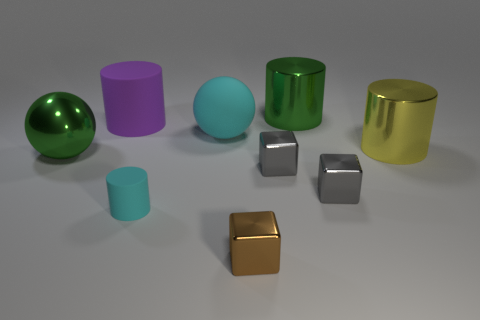Add 1 cyan spheres. How many objects exist? 10 Subtract all cylinders. How many objects are left? 5 Subtract 0 gray spheres. How many objects are left? 9 Subtract all small red matte balls. Subtract all small things. How many objects are left? 5 Add 7 big cylinders. How many big cylinders are left? 10 Add 1 cyan matte things. How many cyan matte things exist? 3 